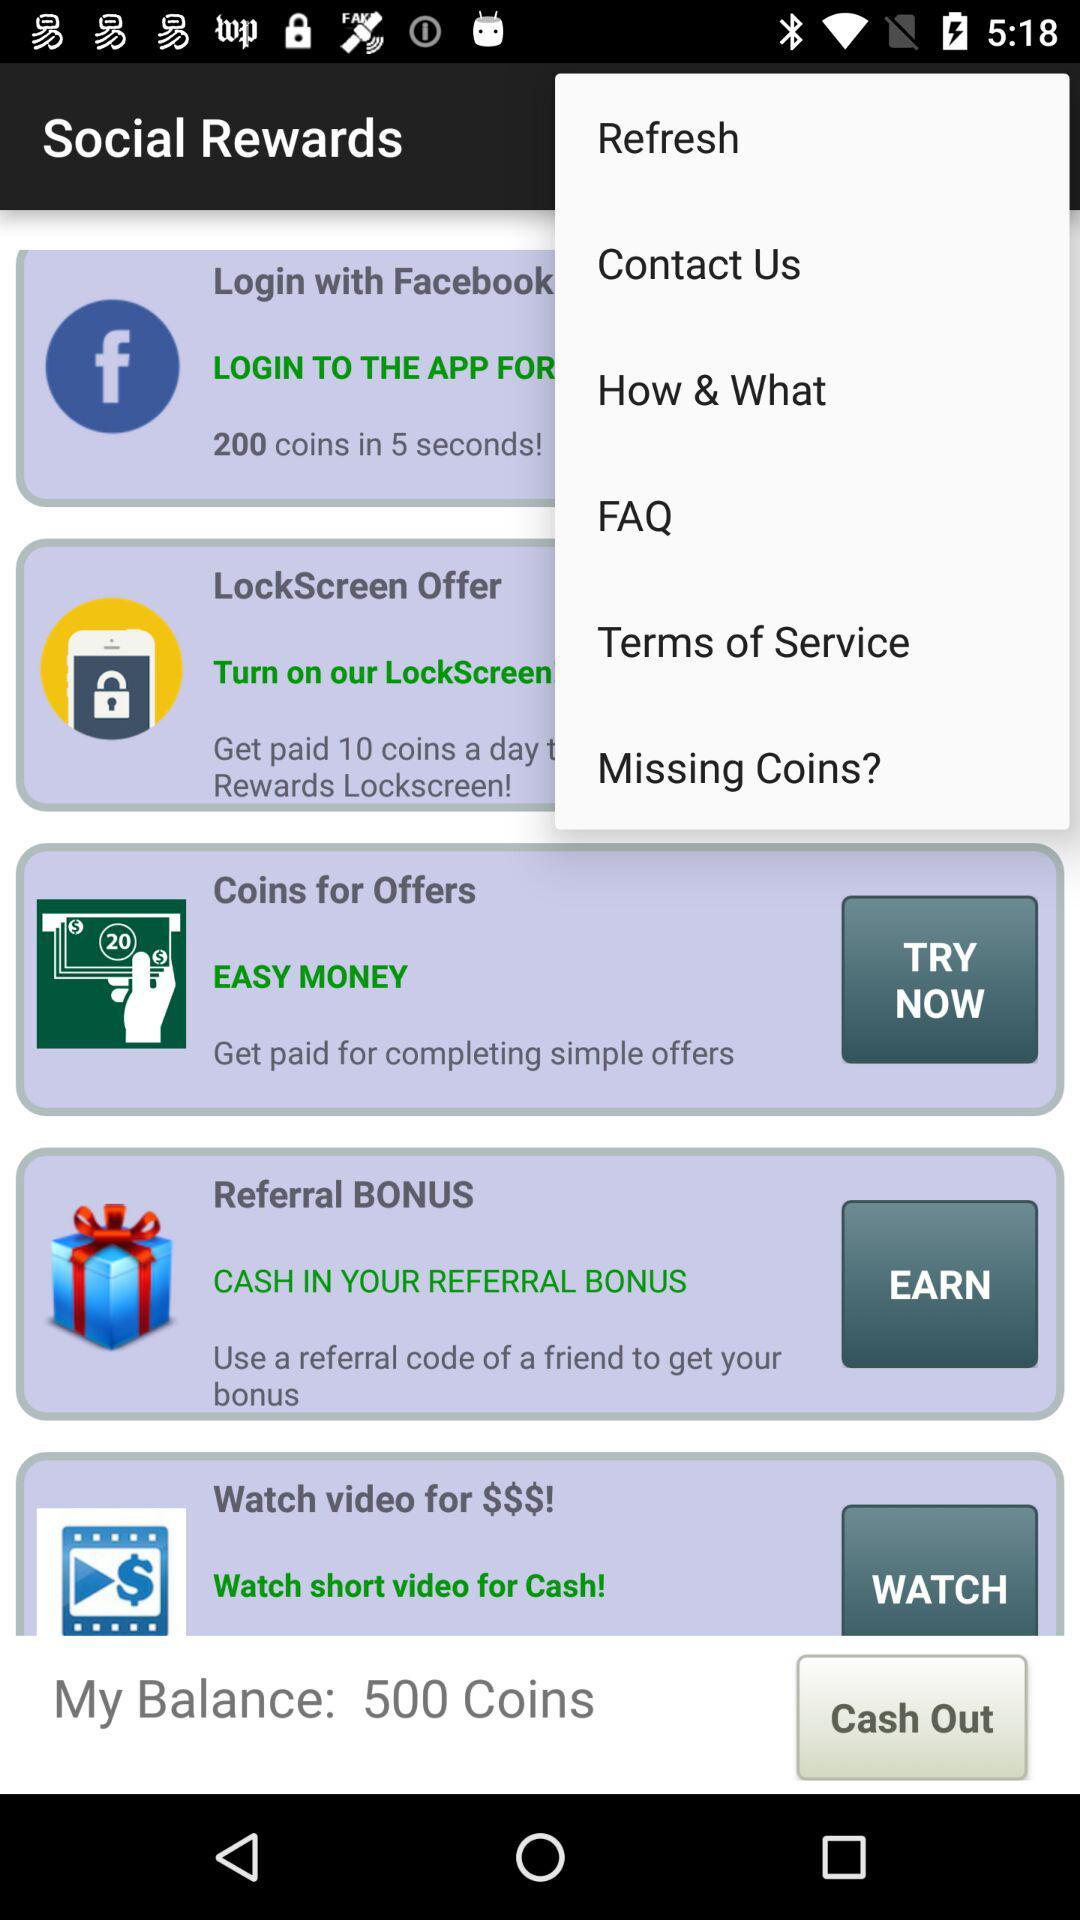How many coins can be earned by logging in with "Facebook"? By logging in with "Facebook", 200 coins can be earned. 